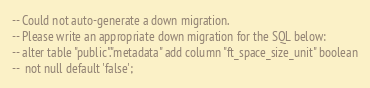Convert code to text. <code><loc_0><loc_0><loc_500><loc_500><_SQL_>-- Could not auto-generate a down migration.
-- Please write an appropriate down migration for the SQL below:
-- alter table "public"."metadata" add column "ft_space_size_unit" boolean
--  not null default 'false';
</code> 